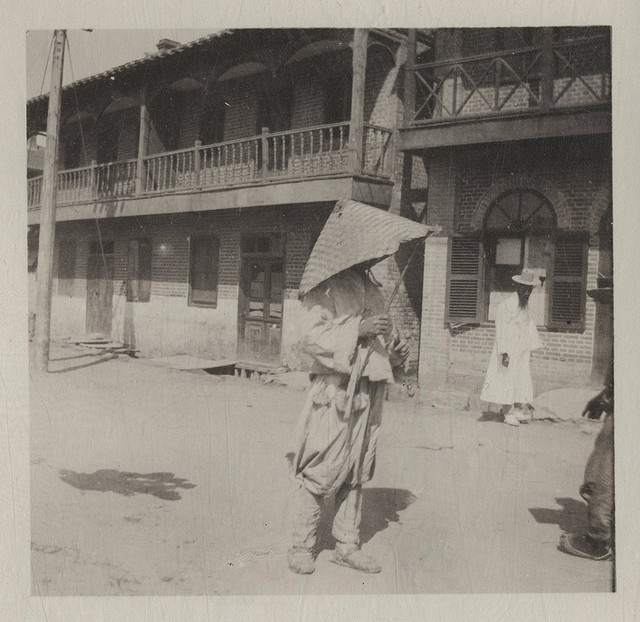Describe the objects in this image and their specific colors. I can see people in lightgray, darkgray, and gray tones, people in lightgray, darkgray, and gray tones, umbrella in lightgray, darkgray, gray, and black tones, and people in lightgray, gray, and black tones in this image. 